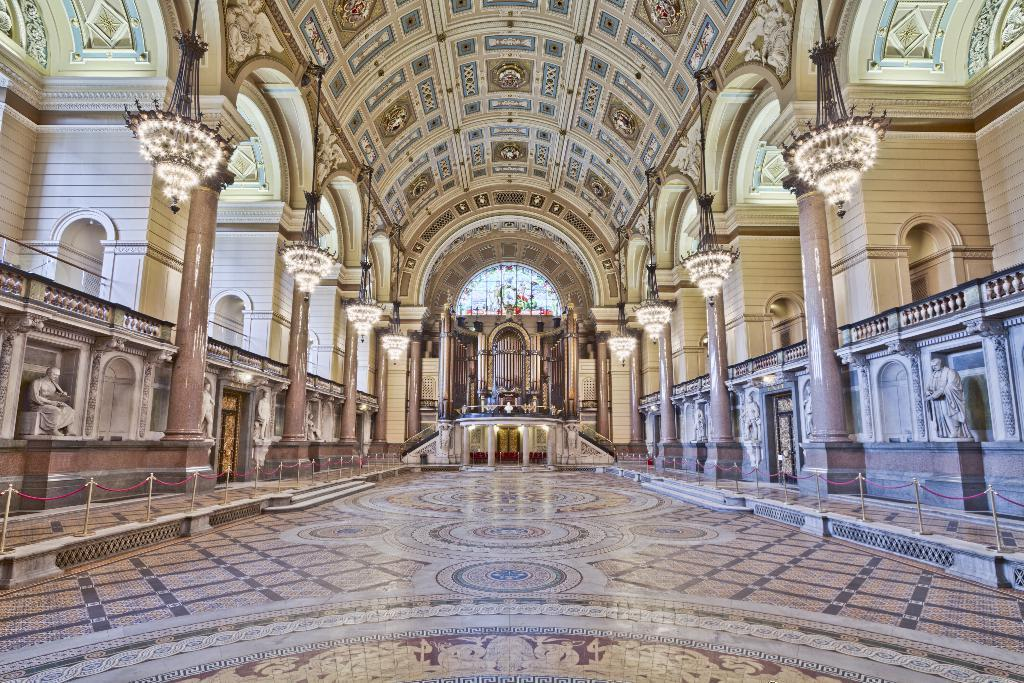What type of location is shown in the image? The image depicts an inside view of a building. What decorative elements can be seen in the image? There are statues and a chandelier with lights visible in the image. What type of glasswork is present in the image? There is a stained glass in the image. Can you see any wounds on the statues in the image? There are no wounds visible on the statues in the image, as statues are inanimate objects and do not have the ability to be wounded. 